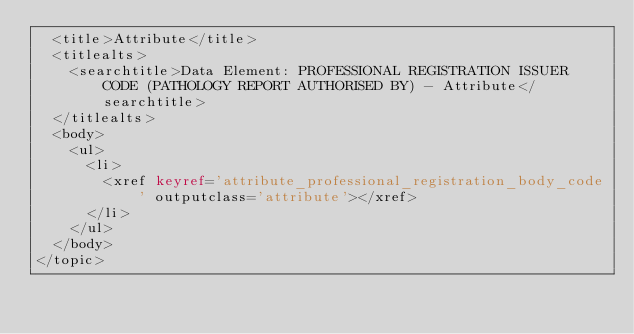<code> <loc_0><loc_0><loc_500><loc_500><_XML_>  <title>Attribute</title>
  <titlealts>
    <searchtitle>Data Element: PROFESSIONAL REGISTRATION ISSUER CODE (PATHOLOGY REPORT AUTHORISED BY) - Attribute</searchtitle>
  </titlealts>
  <body>
    <ul>
      <li>
        <xref keyref='attribute_professional_registration_body_code' outputclass='attribute'></xref>
      </li>
    </ul>
  </body>
</topic></code> 